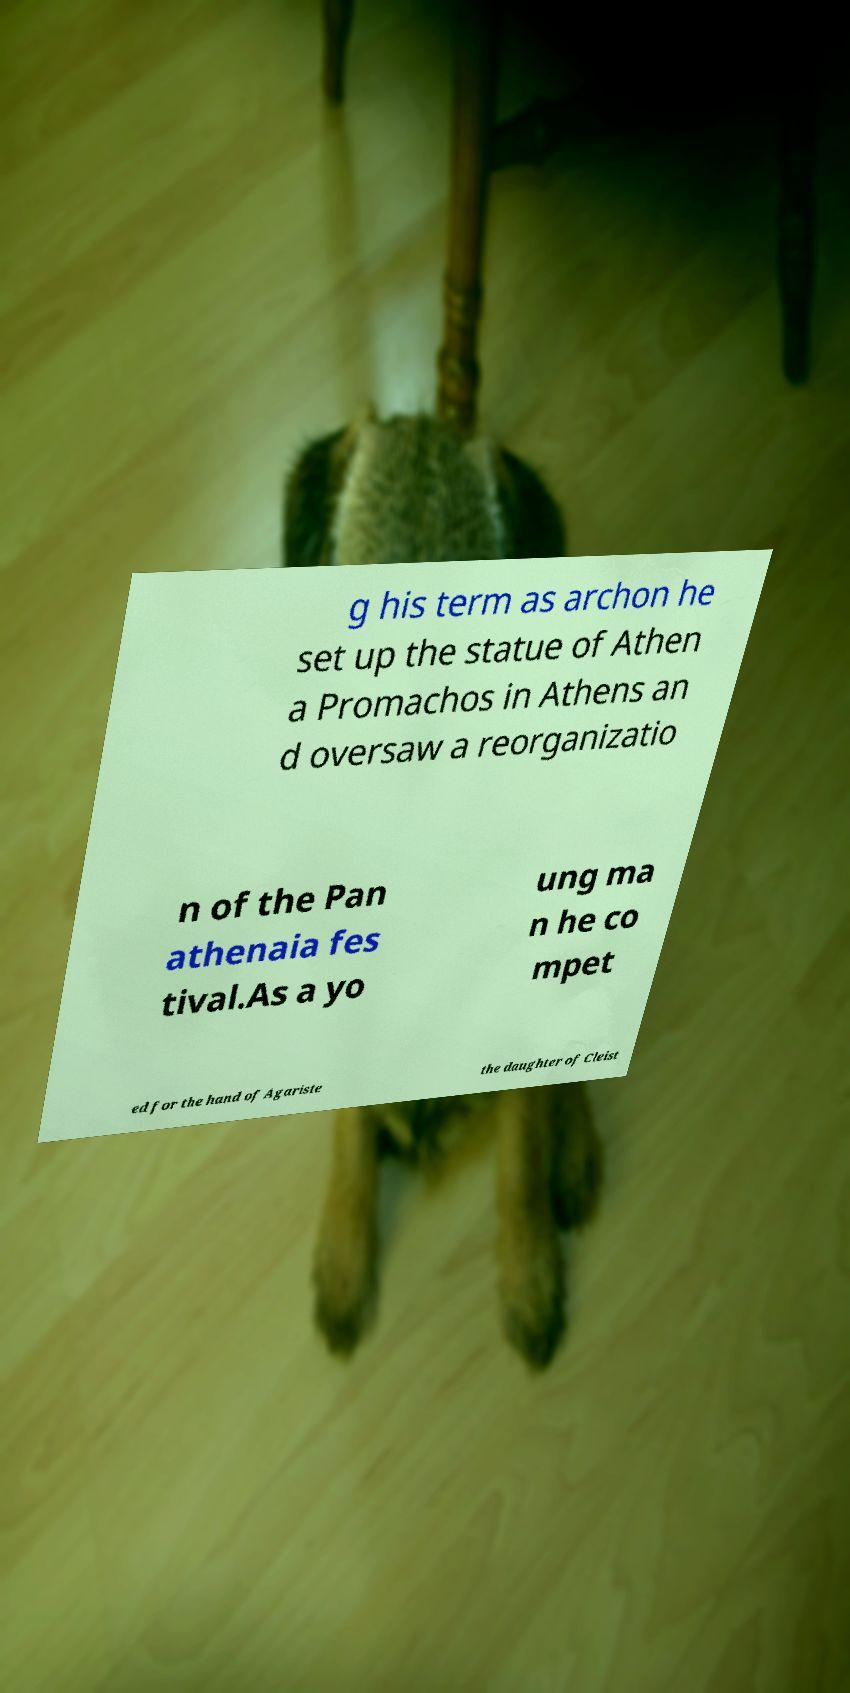Please identify and transcribe the text found in this image. g his term as archon he set up the statue of Athen a Promachos in Athens an d oversaw a reorganizatio n of the Pan athenaia fes tival.As a yo ung ma n he co mpet ed for the hand of Agariste the daughter of Cleist 